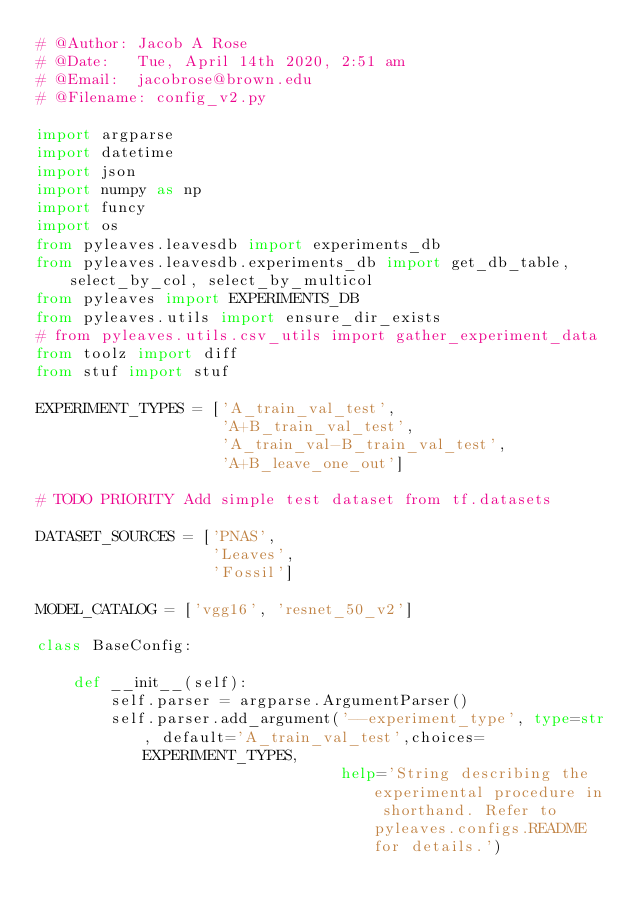<code> <loc_0><loc_0><loc_500><loc_500><_Python_># @Author: Jacob A Rose
# @Date:   Tue, April 14th 2020, 2:51 am
# @Email:  jacobrose@brown.edu
# @Filename: config_v2.py

import argparse
import datetime
import json
import numpy as np
import funcy
import os
from pyleaves.leavesdb import experiments_db
from pyleaves.leavesdb.experiments_db import get_db_table, select_by_col, select_by_multicol
from pyleaves import EXPERIMENTS_DB
from pyleaves.utils import ensure_dir_exists
# from pyleaves.utils.csv_utils import gather_experiment_data
from toolz import diff
from stuf import stuf

EXPERIMENT_TYPES = ['A_train_val_test',
                    'A+B_train_val_test',
                    'A_train_val-B_train_val_test',
                    'A+B_leave_one_out']

# TODO PRIORITY Add simple test dataset from tf.datasets

DATASET_SOURCES = ['PNAS',
                   'Leaves',
                   'Fossil']

MODEL_CATALOG = ['vgg16', 'resnet_50_v2']

class BaseConfig:

    def __init__(self):
        self.parser = argparse.ArgumentParser()
        self.parser.add_argument('--experiment_type', type=str, default='A_train_val_test',choices=EXPERIMENT_TYPES,
                                 help='String describing the experimental procedure in shorthand. Refer to pyleaves.configs.README for details.')</code> 